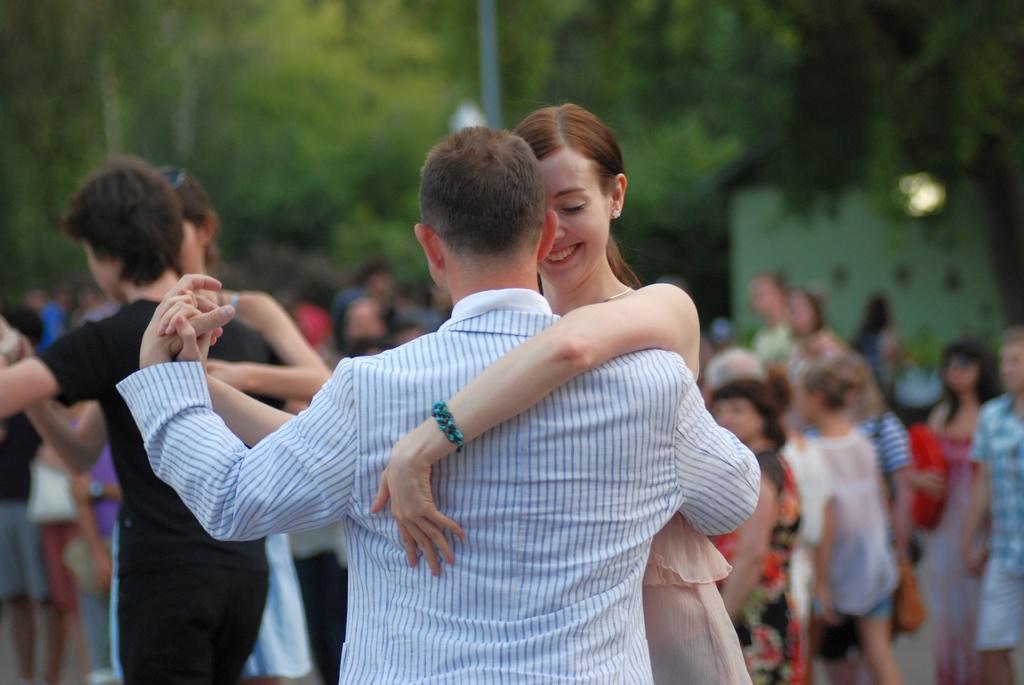Can you describe this image briefly? In this picture we can see a woman smiling and four people dancing and at the back of them we can see a group of people and in the background we can see a shed, pole, trees and it is blurry 